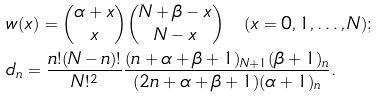Convert formula to latex. <formula><loc_0><loc_0><loc_500><loc_500>& w ( x ) = \binom { \alpha + x } { x } \binom { N + \beta - x } { N - x } \quad ( x = 0 , 1 , \dots , N ) ; \\ & d _ { n } = \frac { n ! ( N - n ) ! } { N ! ^ { 2 } } \frac { ( n + \alpha + \beta + 1 ) _ { N + 1 } ( \beta + 1 ) _ { n } } { ( 2 n + \alpha + \beta + 1 ) ( \alpha + 1 ) _ { n } } .</formula> 